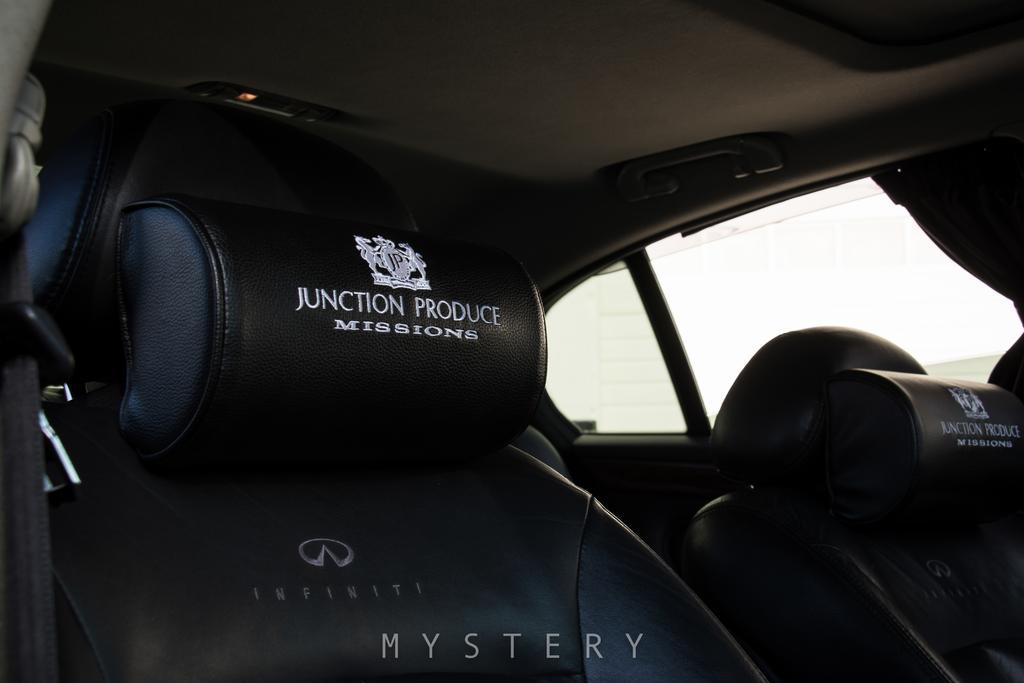Could you give a brief overview of what you see in this image? This image is taken inside the car where we can see that there are two seats in the front. In the background there are two other seats. On the right side there is a window. On the left side there is a seat belt. At the top there is a handle. 